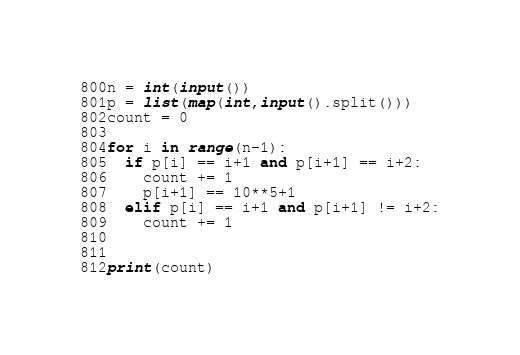Convert code to text. <code><loc_0><loc_0><loc_500><loc_500><_Python_>n = int(input())
p = list(map(int,input().split()))
count = 0

for i in range(n-1):
  if p[i] == i+1 and p[i+1] == i+2:
    count += 1
    p[i+1] == 10**5+1
  elif p[i] == i+1 and p[i+1] != i+2:
    count += 1
    
    
print(count)</code> 